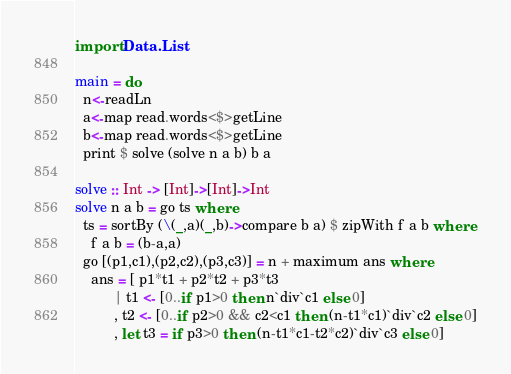<code> <loc_0><loc_0><loc_500><loc_500><_Haskell_>import Data.List

main = do
  n<-readLn
  a<-map read.words<$>getLine
  b<-map read.words<$>getLine
  print $ solve (solve n a b) b a

solve :: Int -> [Int]->[Int]->Int
solve n a b = go ts where
  ts = sortBy (\(_,a)(_,b)->compare b a) $ zipWith f a b where
    f a b = (b-a,a)
  go [(p1,c1),(p2,c2),(p3,c3)] = n + maximum ans where
    ans = [ p1*t1 + p2*t2 + p3*t3
          | t1 <- [0..if p1>0 then n`div`c1 else 0]
          , t2 <- [0..if p2>0 && c2<c1 then (n-t1*c1)`div`c2 else 0]
          , let t3 = if p3>0 then (n-t1*c1-t2*c2)`div`c3 else 0]</code> 